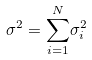<formula> <loc_0><loc_0><loc_500><loc_500>\sigma ^ { 2 } = { \sum _ { i = 1 } ^ { N } } \sigma _ { i } ^ { 2 }</formula> 